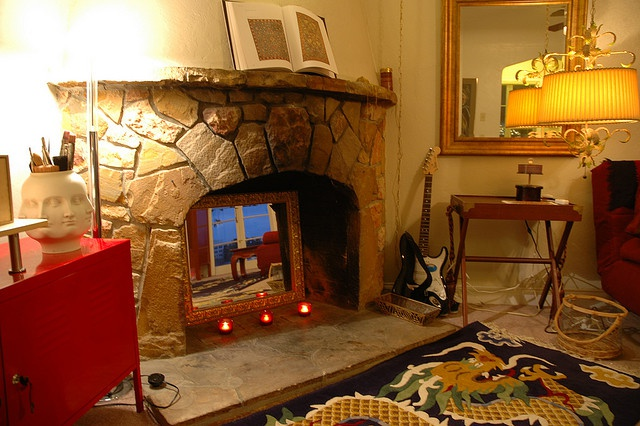Describe the objects in this image and their specific colors. I can see book in khaki, tan, olive, and maroon tones and couch in khaki, black, maroon, olive, and tan tones in this image. 